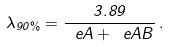<formula> <loc_0><loc_0><loc_500><loc_500>\lambda _ { 9 0 \% } = \frac { 3 . 8 9 } { \ e A + \ e A B } \, .</formula> 